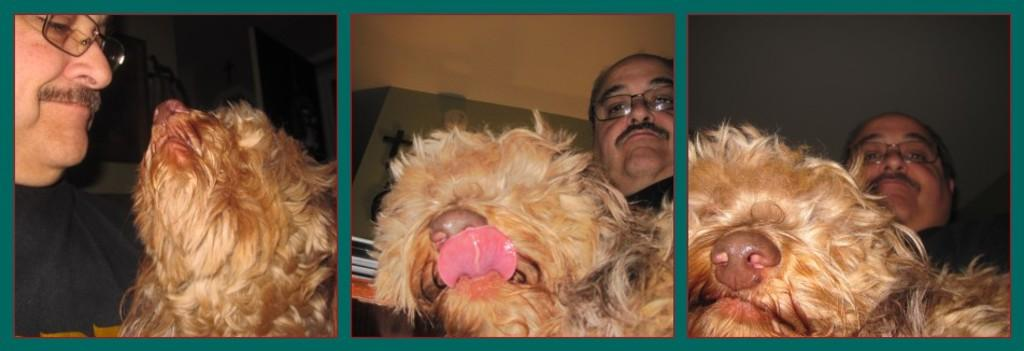What type of artwork is depicted in the image? The image is a collage. What is a common feature of each individual image within the collage? Each image in the collage contains a person wearing specs. What other element is present in each image within the collage? Each image in the collage contains an animal. What is the texture of the writer's desk in the image? There is no writer or desk present in the image; it is a collage featuring images of people wearing specs and animals. 